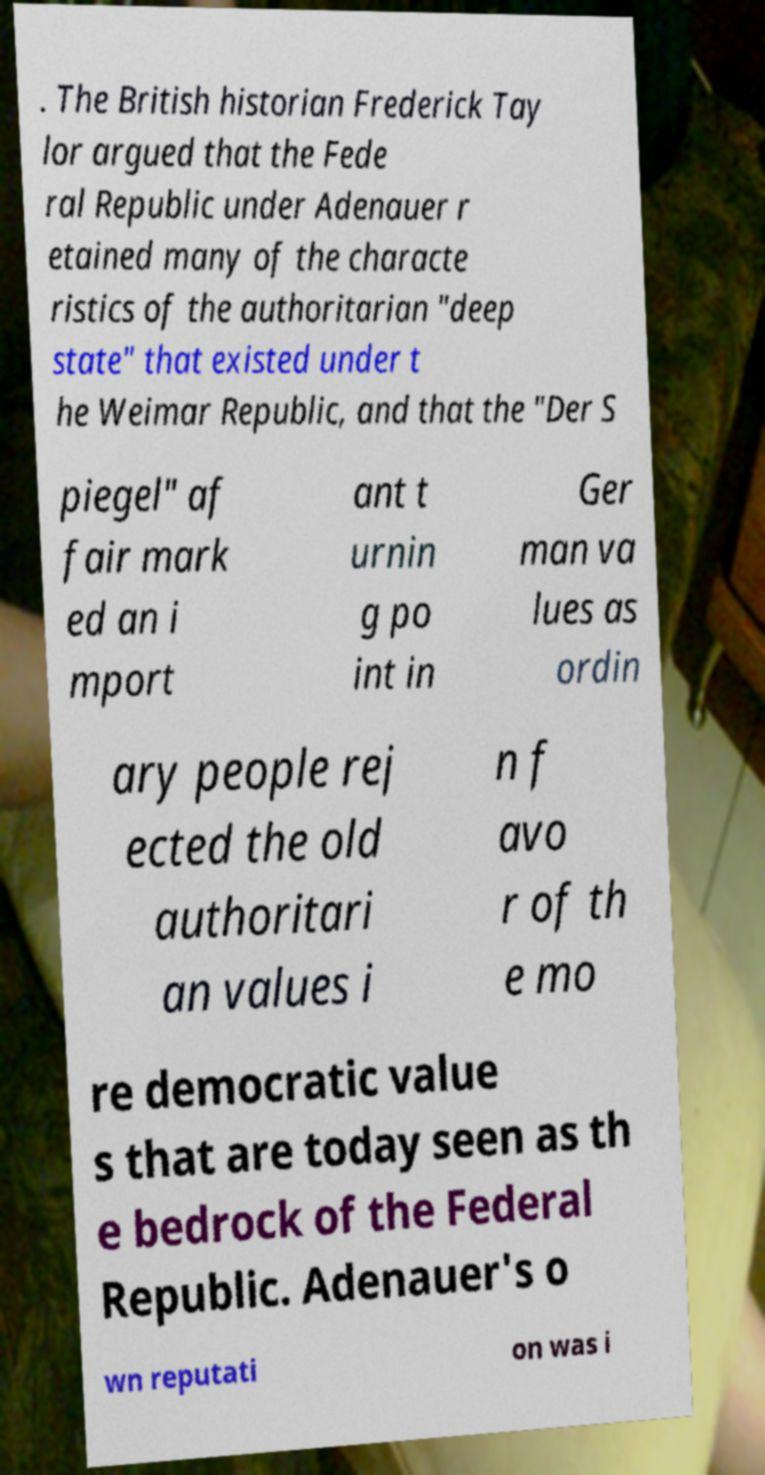Can you accurately transcribe the text from the provided image for me? . The British historian Frederick Tay lor argued that the Fede ral Republic under Adenauer r etained many of the characte ristics of the authoritarian "deep state" that existed under t he Weimar Republic, and that the "Der S piegel" af fair mark ed an i mport ant t urnin g po int in Ger man va lues as ordin ary people rej ected the old authoritari an values i n f avo r of th e mo re democratic value s that are today seen as th e bedrock of the Federal Republic. Adenauer's o wn reputati on was i 